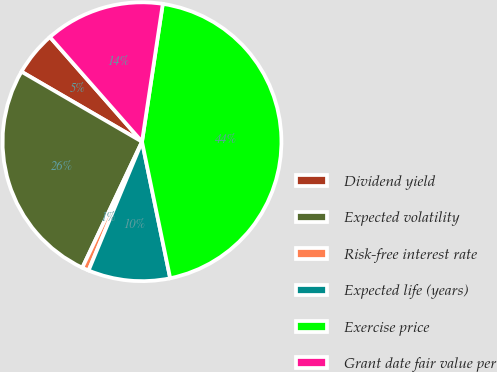Convert chart. <chart><loc_0><loc_0><loc_500><loc_500><pie_chart><fcel>Dividend yield<fcel>Expected volatility<fcel>Risk-free interest rate<fcel>Expected life (years)<fcel>Exercise price<fcel>Grant date fair value per<nl><fcel>5.14%<fcel>26.33%<fcel>0.78%<fcel>9.5%<fcel>44.37%<fcel>13.86%<nl></chart> 